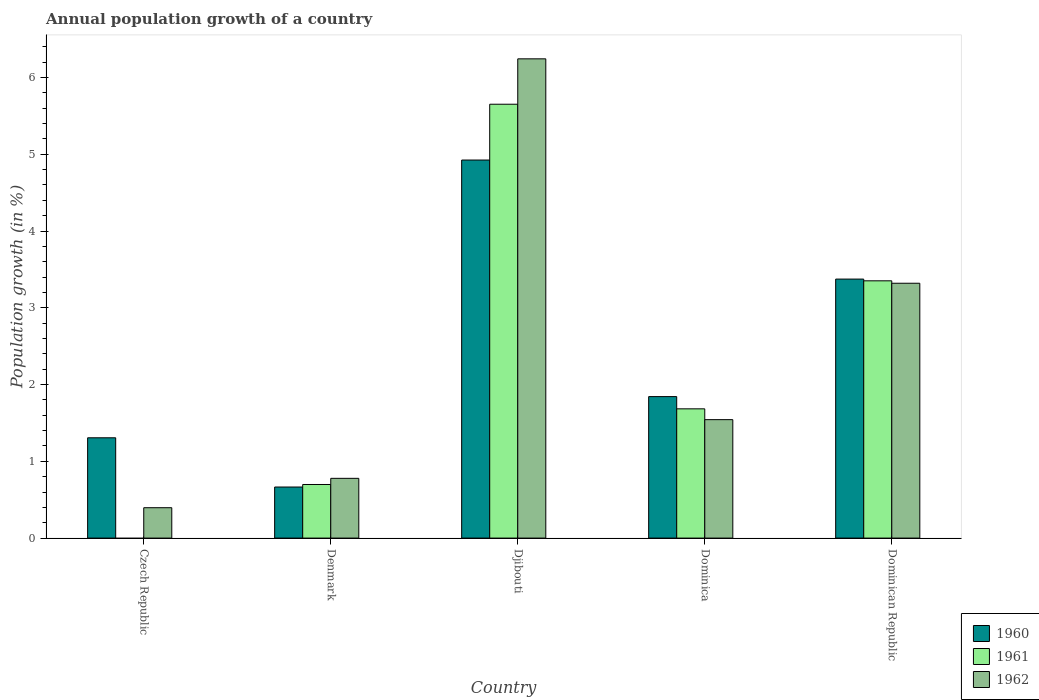How many different coloured bars are there?
Your answer should be compact. 3. How many groups of bars are there?
Make the answer very short. 5. Are the number of bars on each tick of the X-axis equal?
Provide a short and direct response. No. How many bars are there on the 3rd tick from the left?
Your answer should be compact. 3. How many bars are there on the 5th tick from the right?
Offer a very short reply. 2. What is the label of the 1st group of bars from the left?
Provide a succinct answer. Czech Republic. What is the annual population growth in 1961 in Dominican Republic?
Give a very brief answer. 3.35. Across all countries, what is the maximum annual population growth in 1961?
Your answer should be very brief. 5.65. In which country was the annual population growth in 1961 maximum?
Your response must be concise. Djibouti. What is the total annual population growth in 1960 in the graph?
Make the answer very short. 12.11. What is the difference between the annual population growth in 1960 in Djibouti and that in Dominican Republic?
Your answer should be compact. 1.55. What is the difference between the annual population growth in 1960 in Djibouti and the annual population growth in 1962 in Czech Republic?
Your response must be concise. 4.53. What is the average annual population growth in 1961 per country?
Offer a very short reply. 2.28. What is the difference between the annual population growth of/in 1961 and annual population growth of/in 1962 in Dominica?
Ensure brevity in your answer.  0.14. In how many countries, is the annual population growth in 1962 greater than 5.6 %?
Keep it short and to the point. 1. What is the ratio of the annual population growth in 1960 in Czech Republic to that in Dominican Republic?
Offer a terse response. 0.39. What is the difference between the highest and the second highest annual population growth in 1962?
Provide a succinct answer. -1.78. What is the difference between the highest and the lowest annual population growth in 1961?
Your answer should be very brief. 5.65. Is it the case that in every country, the sum of the annual population growth in 1960 and annual population growth in 1961 is greater than the annual population growth in 1962?
Give a very brief answer. Yes. How many bars are there?
Make the answer very short. 14. Are all the bars in the graph horizontal?
Your answer should be very brief. No. How many countries are there in the graph?
Your answer should be very brief. 5. Are the values on the major ticks of Y-axis written in scientific E-notation?
Your response must be concise. No. Does the graph contain any zero values?
Your answer should be compact. Yes. Does the graph contain grids?
Keep it short and to the point. No. How are the legend labels stacked?
Make the answer very short. Vertical. What is the title of the graph?
Offer a terse response. Annual population growth of a country. Does "1998" appear as one of the legend labels in the graph?
Keep it short and to the point. No. What is the label or title of the Y-axis?
Provide a short and direct response. Population growth (in %). What is the Population growth (in %) in 1960 in Czech Republic?
Ensure brevity in your answer.  1.31. What is the Population growth (in %) of 1962 in Czech Republic?
Offer a very short reply. 0.4. What is the Population growth (in %) in 1960 in Denmark?
Offer a very short reply. 0.67. What is the Population growth (in %) in 1961 in Denmark?
Give a very brief answer. 0.7. What is the Population growth (in %) of 1962 in Denmark?
Ensure brevity in your answer.  0.78. What is the Population growth (in %) in 1960 in Djibouti?
Keep it short and to the point. 4.92. What is the Population growth (in %) of 1961 in Djibouti?
Provide a succinct answer. 5.65. What is the Population growth (in %) of 1962 in Djibouti?
Provide a short and direct response. 6.24. What is the Population growth (in %) in 1960 in Dominica?
Provide a short and direct response. 1.84. What is the Population growth (in %) in 1961 in Dominica?
Your answer should be compact. 1.68. What is the Population growth (in %) in 1962 in Dominica?
Provide a succinct answer. 1.54. What is the Population growth (in %) in 1960 in Dominican Republic?
Your response must be concise. 3.37. What is the Population growth (in %) of 1961 in Dominican Republic?
Provide a succinct answer. 3.35. What is the Population growth (in %) of 1962 in Dominican Republic?
Give a very brief answer. 3.32. Across all countries, what is the maximum Population growth (in %) of 1960?
Offer a terse response. 4.92. Across all countries, what is the maximum Population growth (in %) in 1961?
Your answer should be compact. 5.65. Across all countries, what is the maximum Population growth (in %) in 1962?
Offer a very short reply. 6.24. Across all countries, what is the minimum Population growth (in %) of 1960?
Give a very brief answer. 0.67. Across all countries, what is the minimum Population growth (in %) of 1962?
Offer a terse response. 0.4. What is the total Population growth (in %) of 1960 in the graph?
Make the answer very short. 12.11. What is the total Population growth (in %) of 1961 in the graph?
Offer a terse response. 11.38. What is the total Population growth (in %) of 1962 in the graph?
Make the answer very short. 12.28. What is the difference between the Population growth (in %) in 1960 in Czech Republic and that in Denmark?
Ensure brevity in your answer.  0.64. What is the difference between the Population growth (in %) in 1962 in Czech Republic and that in Denmark?
Provide a short and direct response. -0.38. What is the difference between the Population growth (in %) of 1960 in Czech Republic and that in Djibouti?
Your answer should be very brief. -3.62. What is the difference between the Population growth (in %) of 1962 in Czech Republic and that in Djibouti?
Offer a very short reply. -5.85. What is the difference between the Population growth (in %) in 1960 in Czech Republic and that in Dominica?
Your answer should be compact. -0.54. What is the difference between the Population growth (in %) of 1962 in Czech Republic and that in Dominica?
Offer a very short reply. -1.15. What is the difference between the Population growth (in %) in 1960 in Czech Republic and that in Dominican Republic?
Provide a succinct answer. -2.07. What is the difference between the Population growth (in %) in 1962 in Czech Republic and that in Dominican Republic?
Offer a terse response. -2.92. What is the difference between the Population growth (in %) in 1960 in Denmark and that in Djibouti?
Ensure brevity in your answer.  -4.26. What is the difference between the Population growth (in %) of 1961 in Denmark and that in Djibouti?
Your response must be concise. -4.95. What is the difference between the Population growth (in %) in 1962 in Denmark and that in Djibouti?
Offer a very short reply. -5.46. What is the difference between the Population growth (in %) of 1960 in Denmark and that in Dominica?
Provide a succinct answer. -1.18. What is the difference between the Population growth (in %) in 1961 in Denmark and that in Dominica?
Your answer should be compact. -0.99. What is the difference between the Population growth (in %) in 1962 in Denmark and that in Dominica?
Your answer should be very brief. -0.76. What is the difference between the Population growth (in %) in 1960 in Denmark and that in Dominican Republic?
Make the answer very short. -2.71. What is the difference between the Population growth (in %) in 1961 in Denmark and that in Dominican Republic?
Offer a terse response. -2.65. What is the difference between the Population growth (in %) in 1962 in Denmark and that in Dominican Republic?
Ensure brevity in your answer.  -2.54. What is the difference between the Population growth (in %) in 1960 in Djibouti and that in Dominica?
Your answer should be compact. 3.08. What is the difference between the Population growth (in %) in 1961 in Djibouti and that in Dominica?
Provide a short and direct response. 3.97. What is the difference between the Population growth (in %) of 1962 in Djibouti and that in Dominica?
Your answer should be compact. 4.7. What is the difference between the Population growth (in %) in 1960 in Djibouti and that in Dominican Republic?
Your answer should be compact. 1.55. What is the difference between the Population growth (in %) in 1961 in Djibouti and that in Dominican Republic?
Make the answer very short. 2.3. What is the difference between the Population growth (in %) in 1962 in Djibouti and that in Dominican Republic?
Provide a short and direct response. 2.92. What is the difference between the Population growth (in %) of 1960 in Dominica and that in Dominican Republic?
Ensure brevity in your answer.  -1.53. What is the difference between the Population growth (in %) of 1961 in Dominica and that in Dominican Republic?
Make the answer very short. -1.67. What is the difference between the Population growth (in %) in 1962 in Dominica and that in Dominican Republic?
Make the answer very short. -1.78. What is the difference between the Population growth (in %) of 1960 in Czech Republic and the Population growth (in %) of 1961 in Denmark?
Offer a very short reply. 0.61. What is the difference between the Population growth (in %) in 1960 in Czech Republic and the Population growth (in %) in 1962 in Denmark?
Your response must be concise. 0.53. What is the difference between the Population growth (in %) of 1960 in Czech Republic and the Population growth (in %) of 1961 in Djibouti?
Your response must be concise. -4.35. What is the difference between the Population growth (in %) of 1960 in Czech Republic and the Population growth (in %) of 1962 in Djibouti?
Offer a terse response. -4.94. What is the difference between the Population growth (in %) in 1960 in Czech Republic and the Population growth (in %) in 1961 in Dominica?
Your answer should be very brief. -0.38. What is the difference between the Population growth (in %) in 1960 in Czech Republic and the Population growth (in %) in 1962 in Dominica?
Make the answer very short. -0.24. What is the difference between the Population growth (in %) of 1960 in Czech Republic and the Population growth (in %) of 1961 in Dominican Republic?
Your answer should be compact. -2.04. What is the difference between the Population growth (in %) in 1960 in Czech Republic and the Population growth (in %) in 1962 in Dominican Republic?
Your answer should be very brief. -2.01. What is the difference between the Population growth (in %) in 1960 in Denmark and the Population growth (in %) in 1961 in Djibouti?
Provide a short and direct response. -4.99. What is the difference between the Population growth (in %) in 1960 in Denmark and the Population growth (in %) in 1962 in Djibouti?
Provide a short and direct response. -5.58. What is the difference between the Population growth (in %) of 1961 in Denmark and the Population growth (in %) of 1962 in Djibouti?
Offer a terse response. -5.54. What is the difference between the Population growth (in %) of 1960 in Denmark and the Population growth (in %) of 1961 in Dominica?
Offer a terse response. -1.02. What is the difference between the Population growth (in %) of 1960 in Denmark and the Population growth (in %) of 1962 in Dominica?
Offer a very short reply. -0.88. What is the difference between the Population growth (in %) in 1961 in Denmark and the Population growth (in %) in 1962 in Dominica?
Give a very brief answer. -0.84. What is the difference between the Population growth (in %) in 1960 in Denmark and the Population growth (in %) in 1961 in Dominican Republic?
Keep it short and to the point. -2.69. What is the difference between the Population growth (in %) of 1960 in Denmark and the Population growth (in %) of 1962 in Dominican Republic?
Your answer should be very brief. -2.65. What is the difference between the Population growth (in %) of 1961 in Denmark and the Population growth (in %) of 1962 in Dominican Republic?
Give a very brief answer. -2.62. What is the difference between the Population growth (in %) in 1960 in Djibouti and the Population growth (in %) in 1961 in Dominica?
Keep it short and to the point. 3.24. What is the difference between the Population growth (in %) in 1960 in Djibouti and the Population growth (in %) in 1962 in Dominica?
Make the answer very short. 3.38. What is the difference between the Population growth (in %) of 1961 in Djibouti and the Population growth (in %) of 1962 in Dominica?
Your response must be concise. 4.11. What is the difference between the Population growth (in %) in 1960 in Djibouti and the Population growth (in %) in 1961 in Dominican Republic?
Provide a short and direct response. 1.57. What is the difference between the Population growth (in %) of 1960 in Djibouti and the Population growth (in %) of 1962 in Dominican Republic?
Your answer should be compact. 1.6. What is the difference between the Population growth (in %) of 1961 in Djibouti and the Population growth (in %) of 1962 in Dominican Republic?
Give a very brief answer. 2.33. What is the difference between the Population growth (in %) in 1960 in Dominica and the Population growth (in %) in 1961 in Dominican Republic?
Offer a terse response. -1.51. What is the difference between the Population growth (in %) in 1960 in Dominica and the Population growth (in %) in 1962 in Dominican Republic?
Ensure brevity in your answer.  -1.48. What is the difference between the Population growth (in %) in 1961 in Dominica and the Population growth (in %) in 1962 in Dominican Republic?
Offer a terse response. -1.64. What is the average Population growth (in %) in 1960 per country?
Your answer should be compact. 2.42. What is the average Population growth (in %) of 1961 per country?
Keep it short and to the point. 2.28. What is the average Population growth (in %) of 1962 per country?
Give a very brief answer. 2.46. What is the difference between the Population growth (in %) in 1960 and Population growth (in %) in 1962 in Czech Republic?
Ensure brevity in your answer.  0.91. What is the difference between the Population growth (in %) in 1960 and Population growth (in %) in 1961 in Denmark?
Make the answer very short. -0.03. What is the difference between the Population growth (in %) of 1960 and Population growth (in %) of 1962 in Denmark?
Provide a succinct answer. -0.11. What is the difference between the Population growth (in %) in 1961 and Population growth (in %) in 1962 in Denmark?
Make the answer very short. -0.08. What is the difference between the Population growth (in %) of 1960 and Population growth (in %) of 1961 in Djibouti?
Your answer should be compact. -0.73. What is the difference between the Population growth (in %) of 1960 and Population growth (in %) of 1962 in Djibouti?
Provide a succinct answer. -1.32. What is the difference between the Population growth (in %) of 1961 and Population growth (in %) of 1962 in Djibouti?
Keep it short and to the point. -0.59. What is the difference between the Population growth (in %) of 1960 and Population growth (in %) of 1961 in Dominica?
Offer a very short reply. 0.16. What is the difference between the Population growth (in %) in 1960 and Population growth (in %) in 1962 in Dominica?
Your answer should be very brief. 0.3. What is the difference between the Population growth (in %) in 1961 and Population growth (in %) in 1962 in Dominica?
Provide a succinct answer. 0.14. What is the difference between the Population growth (in %) in 1960 and Population growth (in %) in 1961 in Dominican Republic?
Make the answer very short. 0.02. What is the difference between the Population growth (in %) in 1960 and Population growth (in %) in 1962 in Dominican Republic?
Make the answer very short. 0.05. What is the difference between the Population growth (in %) in 1961 and Population growth (in %) in 1962 in Dominican Republic?
Offer a very short reply. 0.03. What is the ratio of the Population growth (in %) in 1960 in Czech Republic to that in Denmark?
Your response must be concise. 1.96. What is the ratio of the Population growth (in %) in 1962 in Czech Republic to that in Denmark?
Offer a very short reply. 0.51. What is the ratio of the Population growth (in %) of 1960 in Czech Republic to that in Djibouti?
Make the answer very short. 0.27. What is the ratio of the Population growth (in %) in 1962 in Czech Republic to that in Djibouti?
Provide a short and direct response. 0.06. What is the ratio of the Population growth (in %) of 1960 in Czech Republic to that in Dominica?
Offer a terse response. 0.71. What is the ratio of the Population growth (in %) of 1962 in Czech Republic to that in Dominica?
Your answer should be very brief. 0.26. What is the ratio of the Population growth (in %) in 1960 in Czech Republic to that in Dominican Republic?
Your answer should be compact. 0.39. What is the ratio of the Population growth (in %) of 1962 in Czech Republic to that in Dominican Republic?
Your answer should be very brief. 0.12. What is the ratio of the Population growth (in %) of 1960 in Denmark to that in Djibouti?
Make the answer very short. 0.14. What is the ratio of the Population growth (in %) in 1961 in Denmark to that in Djibouti?
Ensure brevity in your answer.  0.12. What is the ratio of the Population growth (in %) in 1962 in Denmark to that in Djibouti?
Make the answer very short. 0.12. What is the ratio of the Population growth (in %) in 1960 in Denmark to that in Dominica?
Provide a short and direct response. 0.36. What is the ratio of the Population growth (in %) of 1961 in Denmark to that in Dominica?
Keep it short and to the point. 0.41. What is the ratio of the Population growth (in %) of 1962 in Denmark to that in Dominica?
Your response must be concise. 0.5. What is the ratio of the Population growth (in %) in 1960 in Denmark to that in Dominican Republic?
Your answer should be very brief. 0.2. What is the ratio of the Population growth (in %) of 1961 in Denmark to that in Dominican Republic?
Ensure brevity in your answer.  0.21. What is the ratio of the Population growth (in %) of 1962 in Denmark to that in Dominican Republic?
Offer a very short reply. 0.23. What is the ratio of the Population growth (in %) in 1960 in Djibouti to that in Dominica?
Your response must be concise. 2.67. What is the ratio of the Population growth (in %) of 1961 in Djibouti to that in Dominica?
Provide a succinct answer. 3.36. What is the ratio of the Population growth (in %) of 1962 in Djibouti to that in Dominica?
Offer a very short reply. 4.05. What is the ratio of the Population growth (in %) in 1960 in Djibouti to that in Dominican Republic?
Provide a short and direct response. 1.46. What is the ratio of the Population growth (in %) in 1961 in Djibouti to that in Dominican Republic?
Provide a short and direct response. 1.69. What is the ratio of the Population growth (in %) in 1962 in Djibouti to that in Dominican Republic?
Your response must be concise. 1.88. What is the ratio of the Population growth (in %) of 1960 in Dominica to that in Dominican Republic?
Keep it short and to the point. 0.55. What is the ratio of the Population growth (in %) in 1961 in Dominica to that in Dominican Republic?
Offer a very short reply. 0.5. What is the ratio of the Population growth (in %) of 1962 in Dominica to that in Dominican Republic?
Provide a short and direct response. 0.46. What is the difference between the highest and the second highest Population growth (in %) in 1960?
Make the answer very short. 1.55. What is the difference between the highest and the second highest Population growth (in %) in 1961?
Keep it short and to the point. 2.3. What is the difference between the highest and the second highest Population growth (in %) of 1962?
Keep it short and to the point. 2.92. What is the difference between the highest and the lowest Population growth (in %) of 1960?
Provide a succinct answer. 4.26. What is the difference between the highest and the lowest Population growth (in %) in 1961?
Offer a very short reply. 5.65. What is the difference between the highest and the lowest Population growth (in %) of 1962?
Provide a succinct answer. 5.85. 